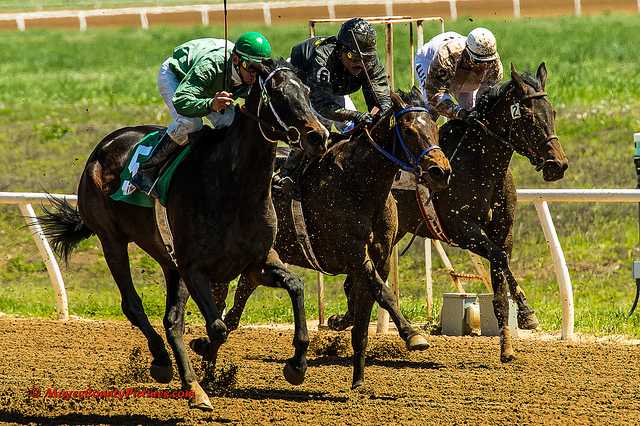Identify the text contained in this image. EJ 2 5 